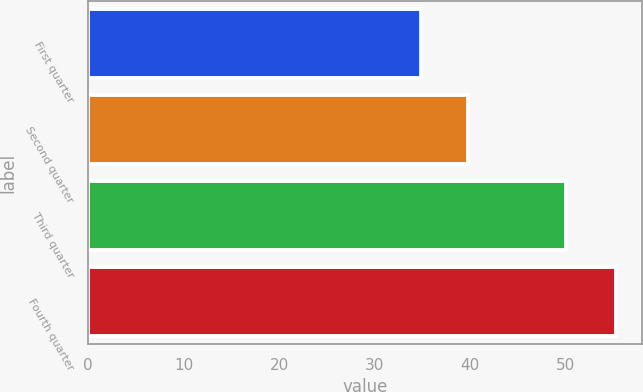Convert chart to OTSL. <chart><loc_0><loc_0><loc_500><loc_500><bar_chart><fcel>First quarter<fcel>Second quarter<fcel>Third quarter<fcel>Fourth quarter<nl><fcel>34.86<fcel>39.74<fcel>50.03<fcel>55.29<nl></chart> 